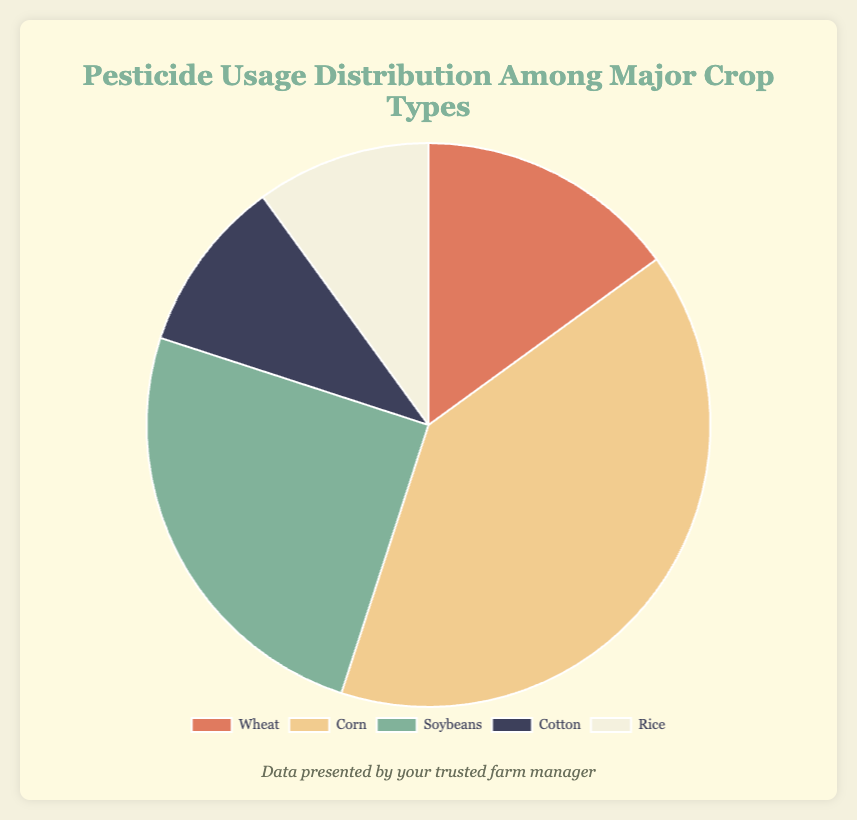What's the most significant category in terms of pesticide usage? The "Corn" category occupies the largest section of the pie chart. By examining the chart, it's clear that Corn has the highest percentage.
Answer: Corn What's the combined pesticide usage percentage for Cotton and Rice? Adding the pesticide usage percentages for Cotton (10%) and Rice (10%) gives 10% + 10% = 20%.
Answer: 20% How does the pesticide usage for Soybeans compare to that for Wheat? Comparing the two sections, Soybeans (25%) has a larger percentage than Wheat (15%).
Answer: Soybeans > Wheat If the pie chart represents total pesticide usage as 100%, what is the percentage usage difference between Corn and Soybeans? Corn has 40% usage and Soybeans have 25%; the difference is 40% - 25% = 15%.
Answer: 15% What could be the median value among these categories? Ordering the pieces from smallest to largest: Cotton (10%), Rice (10%), Wheat (15%), Soybeans (25%), Corn (40%), the median value is the middle one: Wheat, which is 15%.
Answer: 15% Which crop type uses the least pesticides according to the chart? Both Cotton and Rice have equal and smallest sections, each contributing 10%.
Answer: Cotton and Rice What colors represent Wheat and Soybeans on the pie chart? The pie chart shows Wheat in a red-ish color (#e07a5f) and Soybeans in a greenish color (#81b29a).
Answer: red, green 